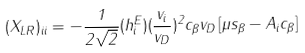Convert formula to latex. <formula><loc_0><loc_0><loc_500><loc_500>( X _ { L R } ) _ { i i } = - \frac { 1 } { 2 \sqrt { 2 } } ( h _ { i } ^ { E } ) ( \frac { v _ { i } } { v _ { D } } ) ^ { 2 } c _ { \beta } v _ { D } \left [ \mu s _ { \beta } - A _ { i } c _ { \beta } \right ]</formula> 